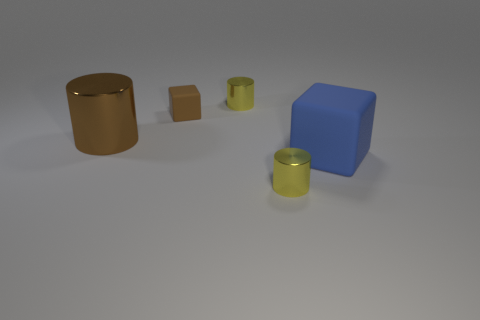Is the color of the large metal thing the same as the tiny rubber block?
Provide a short and direct response. Yes. There is a tiny object in front of the blue thing; what is its shape?
Your answer should be compact. Cylinder. The other object that is the same material as the tiny brown object is what size?
Keep it short and to the point. Large. There is a metal thing that is on the right side of the tiny brown thing and in front of the brown rubber object; what shape is it?
Provide a succinct answer. Cylinder. Do the cylinder to the left of the brown rubber object and the small rubber thing have the same color?
Give a very brief answer. Yes. There is a yellow metallic thing behind the blue rubber cube; does it have the same shape as the big object that is behind the large blue rubber cube?
Ensure brevity in your answer.  Yes. How big is the rubber block that is in front of the large brown thing?
Provide a succinct answer. Large. There is a brown thing that is in front of the brown block that is left of the large matte object; what size is it?
Make the answer very short. Large. Are there more green rubber blocks than small yellow metallic objects?
Give a very brief answer. No. Are there more brown things in front of the small cube than big brown things that are behind the brown metal object?
Offer a very short reply. Yes. 